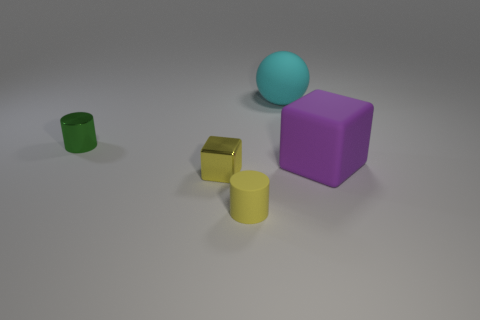What number of things are either small green cylinders or brown shiny spheres?
Make the answer very short. 1. What is the shape of the large rubber object that is to the left of the large thing in front of the metal cylinder?
Give a very brief answer. Sphere. What number of other things are there of the same material as the yellow cylinder
Your response must be concise. 2. Are the sphere and the tiny cylinder that is on the right side of the tiny green metallic object made of the same material?
Ensure brevity in your answer.  Yes. What number of things are small metallic objects that are on the left side of the yellow metallic block or small things that are to the left of the yellow cylinder?
Keep it short and to the point. 2. What number of other objects are the same color as the small shiny block?
Offer a very short reply. 1. Is the number of tiny yellow objects that are on the right side of the ball greater than the number of small yellow cylinders on the left side of the small yellow shiny cube?
Ensure brevity in your answer.  No. What number of cylinders are large cyan rubber objects or yellow metallic objects?
Offer a very short reply. 0. How many objects are big things behind the tiny green shiny cylinder or purple balls?
Ensure brevity in your answer.  1. What shape is the small yellow object behind the yellow object that is in front of the yellow object to the left of the small yellow cylinder?
Ensure brevity in your answer.  Cube. 